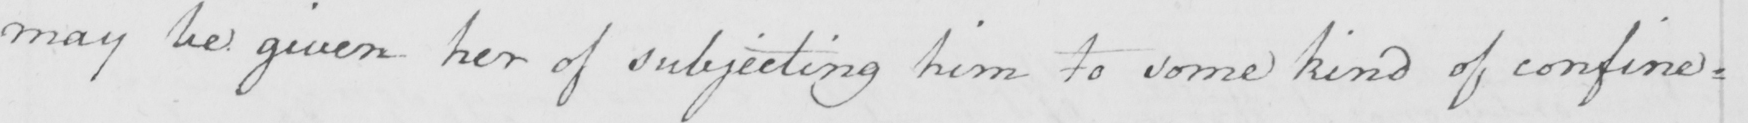What text is written in this handwritten line? may be given her of subjecting him to some kind of confine= 